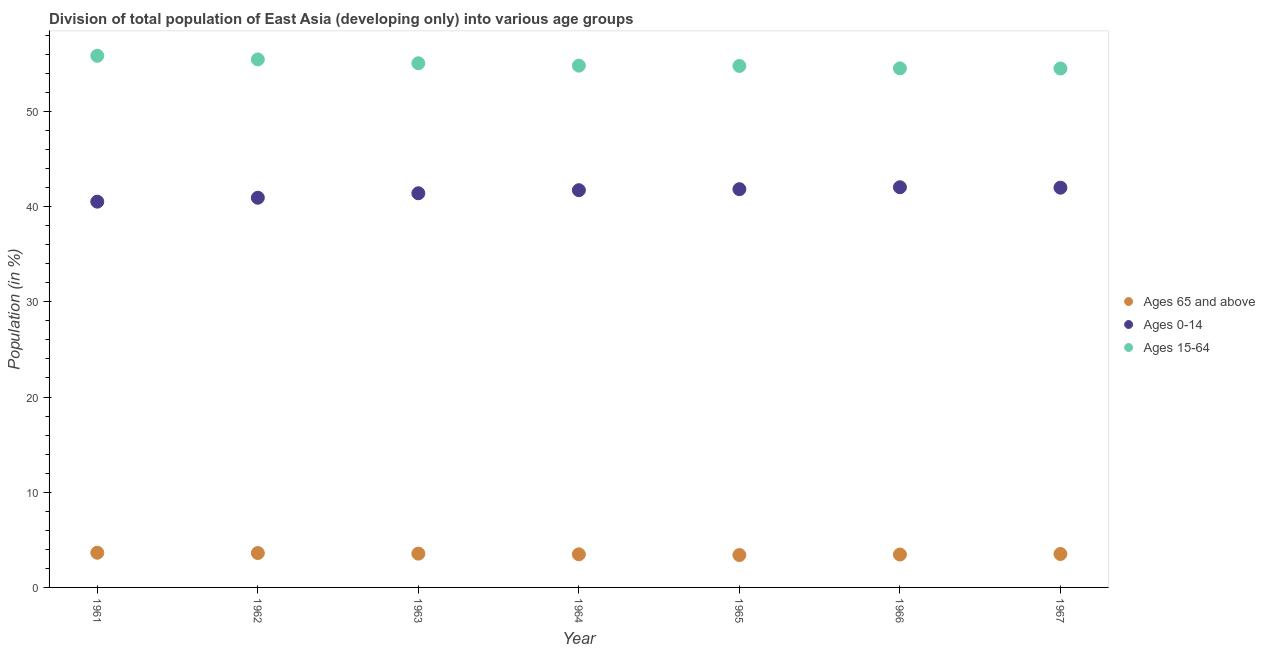How many different coloured dotlines are there?
Your answer should be very brief. 3. What is the percentage of population within the age-group of 65 and above in 1965?
Your answer should be very brief. 3.4. Across all years, what is the maximum percentage of population within the age-group of 65 and above?
Offer a terse response. 3.64. Across all years, what is the minimum percentage of population within the age-group of 65 and above?
Provide a short and direct response. 3.4. In which year was the percentage of population within the age-group 0-14 maximum?
Keep it short and to the point. 1966. In which year was the percentage of population within the age-group of 65 and above minimum?
Make the answer very short. 1965. What is the total percentage of population within the age-group 15-64 in the graph?
Ensure brevity in your answer.  384.93. What is the difference between the percentage of population within the age-group of 65 and above in 1961 and that in 1964?
Keep it short and to the point. 0.17. What is the difference between the percentage of population within the age-group 15-64 in 1963 and the percentage of population within the age-group 0-14 in 1967?
Your answer should be compact. 13.06. What is the average percentage of population within the age-group 0-14 per year?
Provide a succinct answer. 41.49. In the year 1966, what is the difference between the percentage of population within the age-group 15-64 and percentage of population within the age-group 0-14?
Give a very brief answer. 12.48. In how many years, is the percentage of population within the age-group of 65 and above greater than 6 %?
Make the answer very short. 0. What is the ratio of the percentage of population within the age-group 0-14 in 1962 to that in 1964?
Provide a short and direct response. 0.98. Is the percentage of population within the age-group 0-14 in 1961 less than that in 1967?
Your answer should be compact. Yes. Is the difference between the percentage of population within the age-group 0-14 in 1961 and 1963 greater than the difference between the percentage of population within the age-group of 65 and above in 1961 and 1963?
Offer a terse response. No. What is the difference between the highest and the second highest percentage of population within the age-group of 65 and above?
Provide a short and direct response. 0.03. What is the difference between the highest and the lowest percentage of population within the age-group of 65 and above?
Your answer should be compact. 0.24. Is the sum of the percentage of population within the age-group 15-64 in 1963 and 1966 greater than the maximum percentage of population within the age-group of 65 and above across all years?
Provide a succinct answer. Yes. Is the percentage of population within the age-group of 65 and above strictly greater than the percentage of population within the age-group 0-14 over the years?
Your response must be concise. No. How many years are there in the graph?
Offer a terse response. 7. What is the difference between two consecutive major ticks on the Y-axis?
Offer a very short reply. 10. Are the values on the major ticks of Y-axis written in scientific E-notation?
Your answer should be compact. No. Does the graph contain any zero values?
Ensure brevity in your answer.  No. Where does the legend appear in the graph?
Your answer should be compact. Center right. How many legend labels are there?
Offer a very short reply. 3. How are the legend labels stacked?
Make the answer very short. Vertical. What is the title of the graph?
Your answer should be very brief. Division of total population of East Asia (developing only) into various age groups
. Does "Agricultural raw materials" appear as one of the legend labels in the graph?
Provide a succinct answer. No. What is the label or title of the X-axis?
Your answer should be compact. Year. What is the Population (in %) in Ages 65 and above in 1961?
Offer a very short reply. 3.64. What is the Population (in %) in Ages 0-14 in 1961?
Ensure brevity in your answer.  40.52. What is the Population (in %) of Ages 15-64 in 1961?
Your answer should be very brief. 55.84. What is the Population (in %) in Ages 65 and above in 1962?
Ensure brevity in your answer.  3.61. What is the Population (in %) of Ages 0-14 in 1962?
Provide a short and direct response. 40.93. What is the Population (in %) of Ages 15-64 in 1962?
Provide a short and direct response. 55.46. What is the Population (in %) of Ages 65 and above in 1963?
Your answer should be compact. 3.55. What is the Population (in %) in Ages 0-14 in 1963?
Provide a succinct answer. 41.4. What is the Population (in %) in Ages 15-64 in 1963?
Ensure brevity in your answer.  55.05. What is the Population (in %) in Ages 65 and above in 1964?
Provide a short and direct response. 3.48. What is the Population (in %) of Ages 0-14 in 1964?
Keep it short and to the point. 41.72. What is the Population (in %) in Ages 15-64 in 1964?
Keep it short and to the point. 54.8. What is the Population (in %) of Ages 65 and above in 1965?
Offer a terse response. 3.4. What is the Population (in %) of Ages 0-14 in 1965?
Keep it short and to the point. 41.83. What is the Population (in %) of Ages 15-64 in 1965?
Provide a short and direct response. 54.77. What is the Population (in %) in Ages 65 and above in 1966?
Provide a succinct answer. 3.46. What is the Population (in %) in Ages 0-14 in 1966?
Your response must be concise. 42.03. What is the Population (in %) of Ages 15-64 in 1966?
Your answer should be very brief. 54.51. What is the Population (in %) of Ages 65 and above in 1967?
Offer a terse response. 3.51. What is the Population (in %) of Ages 0-14 in 1967?
Provide a short and direct response. 41.99. What is the Population (in %) of Ages 15-64 in 1967?
Ensure brevity in your answer.  54.5. Across all years, what is the maximum Population (in %) of Ages 65 and above?
Ensure brevity in your answer.  3.64. Across all years, what is the maximum Population (in %) in Ages 0-14?
Your answer should be very brief. 42.03. Across all years, what is the maximum Population (in %) in Ages 15-64?
Ensure brevity in your answer.  55.84. Across all years, what is the minimum Population (in %) of Ages 65 and above?
Provide a short and direct response. 3.4. Across all years, what is the minimum Population (in %) in Ages 0-14?
Your response must be concise. 40.52. Across all years, what is the minimum Population (in %) in Ages 15-64?
Make the answer very short. 54.5. What is the total Population (in %) of Ages 65 and above in the graph?
Give a very brief answer. 24.65. What is the total Population (in %) in Ages 0-14 in the graph?
Your answer should be very brief. 290.41. What is the total Population (in %) of Ages 15-64 in the graph?
Ensure brevity in your answer.  384.93. What is the difference between the Population (in %) of Ages 65 and above in 1961 and that in 1962?
Your response must be concise. 0.03. What is the difference between the Population (in %) in Ages 0-14 in 1961 and that in 1962?
Provide a short and direct response. -0.41. What is the difference between the Population (in %) of Ages 15-64 in 1961 and that in 1962?
Provide a succinct answer. 0.38. What is the difference between the Population (in %) of Ages 65 and above in 1961 and that in 1963?
Keep it short and to the point. 0.09. What is the difference between the Population (in %) of Ages 0-14 in 1961 and that in 1963?
Give a very brief answer. -0.88. What is the difference between the Population (in %) in Ages 15-64 in 1961 and that in 1963?
Your answer should be compact. 0.79. What is the difference between the Population (in %) in Ages 65 and above in 1961 and that in 1964?
Your answer should be compact. 0.17. What is the difference between the Population (in %) in Ages 0-14 in 1961 and that in 1964?
Your response must be concise. -1.2. What is the difference between the Population (in %) of Ages 15-64 in 1961 and that in 1964?
Make the answer very short. 1.04. What is the difference between the Population (in %) in Ages 65 and above in 1961 and that in 1965?
Ensure brevity in your answer.  0.24. What is the difference between the Population (in %) in Ages 0-14 in 1961 and that in 1965?
Offer a very short reply. -1.31. What is the difference between the Population (in %) in Ages 15-64 in 1961 and that in 1965?
Ensure brevity in your answer.  1.07. What is the difference between the Population (in %) in Ages 65 and above in 1961 and that in 1966?
Offer a very short reply. 0.19. What is the difference between the Population (in %) in Ages 0-14 in 1961 and that in 1966?
Ensure brevity in your answer.  -1.51. What is the difference between the Population (in %) of Ages 15-64 in 1961 and that in 1966?
Offer a terse response. 1.32. What is the difference between the Population (in %) in Ages 65 and above in 1961 and that in 1967?
Ensure brevity in your answer.  0.13. What is the difference between the Population (in %) of Ages 0-14 in 1961 and that in 1967?
Your answer should be compact. -1.47. What is the difference between the Population (in %) in Ages 15-64 in 1961 and that in 1967?
Make the answer very short. 1.34. What is the difference between the Population (in %) of Ages 65 and above in 1962 and that in 1963?
Provide a succinct answer. 0.06. What is the difference between the Population (in %) of Ages 0-14 in 1962 and that in 1963?
Your response must be concise. -0.47. What is the difference between the Population (in %) in Ages 15-64 in 1962 and that in 1963?
Give a very brief answer. 0.41. What is the difference between the Population (in %) of Ages 65 and above in 1962 and that in 1964?
Offer a very short reply. 0.13. What is the difference between the Population (in %) in Ages 0-14 in 1962 and that in 1964?
Make the answer very short. -0.79. What is the difference between the Population (in %) of Ages 15-64 in 1962 and that in 1964?
Your answer should be compact. 0.66. What is the difference between the Population (in %) in Ages 65 and above in 1962 and that in 1965?
Provide a short and direct response. 0.21. What is the difference between the Population (in %) of Ages 0-14 in 1962 and that in 1965?
Keep it short and to the point. -0.9. What is the difference between the Population (in %) of Ages 15-64 in 1962 and that in 1965?
Your answer should be very brief. 0.69. What is the difference between the Population (in %) of Ages 65 and above in 1962 and that in 1966?
Your response must be concise. 0.16. What is the difference between the Population (in %) of Ages 0-14 in 1962 and that in 1966?
Provide a succinct answer. -1.1. What is the difference between the Population (in %) in Ages 15-64 in 1962 and that in 1966?
Give a very brief answer. 0.95. What is the difference between the Population (in %) in Ages 65 and above in 1962 and that in 1967?
Make the answer very short. 0.1. What is the difference between the Population (in %) of Ages 0-14 in 1962 and that in 1967?
Make the answer very short. -1.06. What is the difference between the Population (in %) of Ages 15-64 in 1962 and that in 1967?
Your answer should be compact. 0.96. What is the difference between the Population (in %) in Ages 65 and above in 1963 and that in 1964?
Keep it short and to the point. 0.07. What is the difference between the Population (in %) of Ages 0-14 in 1963 and that in 1964?
Provide a short and direct response. -0.32. What is the difference between the Population (in %) in Ages 15-64 in 1963 and that in 1964?
Your answer should be compact. 0.25. What is the difference between the Population (in %) in Ages 65 and above in 1963 and that in 1965?
Keep it short and to the point. 0.15. What is the difference between the Population (in %) of Ages 0-14 in 1963 and that in 1965?
Keep it short and to the point. -0.43. What is the difference between the Population (in %) in Ages 15-64 in 1963 and that in 1965?
Make the answer very short. 0.28. What is the difference between the Population (in %) of Ages 65 and above in 1963 and that in 1966?
Ensure brevity in your answer.  0.09. What is the difference between the Population (in %) of Ages 0-14 in 1963 and that in 1966?
Provide a short and direct response. -0.63. What is the difference between the Population (in %) of Ages 15-64 in 1963 and that in 1966?
Give a very brief answer. 0.54. What is the difference between the Population (in %) in Ages 65 and above in 1963 and that in 1967?
Give a very brief answer. 0.04. What is the difference between the Population (in %) in Ages 0-14 in 1963 and that in 1967?
Offer a terse response. -0.59. What is the difference between the Population (in %) of Ages 15-64 in 1963 and that in 1967?
Provide a succinct answer. 0.55. What is the difference between the Population (in %) of Ages 65 and above in 1964 and that in 1965?
Your answer should be very brief. 0.08. What is the difference between the Population (in %) of Ages 0-14 in 1964 and that in 1965?
Ensure brevity in your answer.  -0.11. What is the difference between the Population (in %) of Ages 15-64 in 1964 and that in 1965?
Offer a terse response. 0.03. What is the difference between the Population (in %) of Ages 65 and above in 1964 and that in 1966?
Ensure brevity in your answer.  0.02. What is the difference between the Population (in %) of Ages 0-14 in 1964 and that in 1966?
Give a very brief answer. -0.31. What is the difference between the Population (in %) of Ages 15-64 in 1964 and that in 1966?
Your answer should be compact. 0.29. What is the difference between the Population (in %) of Ages 65 and above in 1964 and that in 1967?
Your answer should be very brief. -0.03. What is the difference between the Population (in %) of Ages 0-14 in 1964 and that in 1967?
Offer a terse response. -0.27. What is the difference between the Population (in %) of Ages 15-64 in 1964 and that in 1967?
Provide a short and direct response. 0.3. What is the difference between the Population (in %) in Ages 65 and above in 1965 and that in 1966?
Make the answer very short. -0.05. What is the difference between the Population (in %) in Ages 0-14 in 1965 and that in 1966?
Your response must be concise. -0.2. What is the difference between the Population (in %) of Ages 15-64 in 1965 and that in 1966?
Your answer should be very brief. 0.26. What is the difference between the Population (in %) in Ages 65 and above in 1965 and that in 1967?
Ensure brevity in your answer.  -0.11. What is the difference between the Population (in %) in Ages 0-14 in 1965 and that in 1967?
Offer a terse response. -0.16. What is the difference between the Population (in %) in Ages 15-64 in 1965 and that in 1967?
Your answer should be very brief. 0.27. What is the difference between the Population (in %) of Ages 65 and above in 1966 and that in 1967?
Provide a succinct answer. -0.06. What is the difference between the Population (in %) of Ages 0-14 in 1966 and that in 1967?
Give a very brief answer. 0.04. What is the difference between the Population (in %) of Ages 15-64 in 1966 and that in 1967?
Your answer should be compact. 0.01. What is the difference between the Population (in %) of Ages 65 and above in 1961 and the Population (in %) of Ages 0-14 in 1962?
Make the answer very short. -37.28. What is the difference between the Population (in %) in Ages 65 and above in 1961 and the Population (in %) in Ages 15-64 in 1962?
Your answer should be compact. -51.81. What is the difference between the Population (in %) in Ages 0-14 in 1961 and the Population (in %) in Ages 15-64 in 1962?
Provide a succinct answer. -14.94. What is the difference between the Population (in %) in Ages 65 and above in 1961 and the Population (in %) in Ages 0-14 in 1963?
Provide a succinct answer. -37.76. What is the difference between the Population (in %) of Ages 65 and above in 1961 and the Population (in %) of Ages 15-64 in 1963?
Provide a succinct answer. -51.41. What is the difference between the Population (in %) of Ages 0-14 in 1961 and the Population (in %) of Ages 15-64 in 1963?
Give a very brief answer. -14.53. What is the difference between the Population (in %) of Ages 65 and above in 1961 and the Population (in %) of Ages 0-14 in 1964?
Ensure brevity in your answer.  -38.08. What is the difference between the Population (in %) in Ages 65 and above in 1961 and the Population (in %) in Ages 15-64 in 1964?
Your answer should be very brief. -51.16. What is the difference between the Population (in %) of Ages 0-14 in 1961 and the Population (in %) of Ages 15-64 in 1964?
Ensure brevity in your answer.  -14.28. What is the difference between the Population (in %) in Ages 65 and above in 1961 and the Population (in %) in Ages 0-14 in 1965?
Make the answer very short. -38.18. What is the difference between the Population (in %) of Ages 65 and above in 1961 and the Population (in %) of Ages 15-64 in 1965?
Make the answer very short. -51.13. What is the difference between the Population (in %) in Ages 0-14 in 1961 and the Population (in %) in Ages 15-64 in 1965?
Offer a terse response. -14.25. What is the difference between the Population (in %) in Ages 65 and above in 1961 and the Population (in %) in Ages 0-14 in 1966?
Provide a succinct answer. -38.39. What is the difference between the Population (in %) in Ages 65 and above in 1961 and the Population (in %) in Ages 15-64 in 1966?
Your answer should be compact. -50.87. What is the difference between the Population (in %) in Ages 0-14 in 1961 and the Population (in %) in Ages 15-64 in 1966?
Your answer should be compact. -14. What is the difference between the Population (in %) of Ages 65 and above in 1961 and the Population (in %) of Ages 0-14 in 1967?
Provide a short and direct response. -38.34. What is the difference between the Population (in %) in Ages 65 and above in 1961 and the Population (in %) in Ages 15-64 in 1967?
Your answer should be compact. -50.86. What is the difference between the Population (in %) in Ages 0-14 in 1961 and the Population (in %) in Ages 15-64 in 1967?
Make the answer very short. -13.98. What is the difference between the Population (in %) in Ages 65 and above in 1962 and the Population (in %) in Ages 0-14 in 1963?
Ensure brevity in your answer.  -37.79. What is the difference between the Population (in %) in Ages 65 and above in 1962 and the Population (in %) in Ages 15-64 in 1963?
Give a very brief answer. -51.44. What is the difference between the Population (in %) in Ages 0-14 in 1962 and the Population (in %) in Ages 15-64 in 1963?
Ensure brevity in your answer.  -14.12. What is the difference between the Population (in %) in Ages 65 and above in 1962 and the Population (in %) in Ages 0-14 in 1964?
Give a very brief answer. -38.11. What is the difference between the Population (in %) in Ages 65 and above in 1962 and the Population (in %) in Ages 15-64 in 1964?
Ensure brevity in your answer.  -51.19. What is the difference between the Population (in %) of Ages 0-14 in 1962 and the Population (in %) of Ages 15-64 in 1964?
Your response must be concise. -13.87. What is the difference between the Population (in %) of Ages 65 and above in 1962 and the Population (in %) of Ages 0-14 in 1965?
Your response must be concise. -38.22. What is the difference between the Population (in %) in Ages 65 and above in 1962 and the Population (in %) in Ages 15-64 in 1965?
Your answer should be compact. -51.16. What is the difference between the Population (in %) in Ages 0-14 in 1962 and the Population (in %) in Ages 15-64 in 1965?
Make the answer very short. -13.84. What is the difference between the Population (in %) of Ages 65 and above in 1962 and the Population (in %) of Ages 0-14 in 1966?
Your answer should be very brief. -38.42. What is the difference between the Population (in %) of Ages 65 and above in 1962 and the Population (in %) of Ages 15-64 in 1966?
Keep it short and to the point. -50.9. What is the difference between the Population (in %) of Ages 0-14 in 1962 and the Population (in %) of Ages 15-64 in 1966?
Your answer should be compact. -13.58. What is the difference between the Population (in %) of Ages 65 and above in 1962 and the Population (in %) of Ages 0-14 in 1967?
Your response must be concise. -38.37. What is the difference between the Population (in %) of Ages 65 and above in 1962 and the Population (in %) of Ages 15-64 in 1967?
Offer a terse response. -50.89. What is the difference between the Population (in %) of Ages 0-14 in 1962 and the Population (in %) of Ages 15-64 in 1967?
Make the answer very short. -13.57. What is the difference between the Population (in %) in Ages 65 and above in 1963 and the Population (in %) in Ages 0-14 in 1964?
Your response must be concise. -38.17. What is the difference between the Population (in %) in Ages 65 and above in 1963 and the Population (in %) in Ages 15-64 in 1964?
Give a very brief answer. -51.25. What is the difference between the Population (in %) in Ages 0-14 in 1963 and the Population (in %) in Ages 15-64 in 1964?
Offer a very short reply. -13.4. What is the difference between the Population (in %) in Ages 65 and above in 1963 and the Population (in %) in Ages 0-14 in 1965?
Make the answer very short. -38.28. What is the difference between the Population (in %) of Ages 65 and above in 1963 and the Population (in %) of Ages 15-64 in 1965?
Give a very brief answer. -51.22. What is the difference between the Population (in %) of Ages 0-14 in 1963 and the Population (in %) of Ages 15-64 in 1965?
Your response must be concise. -13.37. What is the difference between the Population (in %) in Ages 65 and above in 1963 and the Population (in %) in Ages 0-14 in 1966?
Ensure brevity in your answer.  -38.48. What is the difference between the Population (in %) of Ages 65 and above in 1963 and the Population (in %) of Ages 15-64 in 1966?
Offer a terse response. -50.96. What is the difference between the Population (in %) in Ages 0-14 in 1963 and the Population (in %) in Ages 15-64 in 1966?
Your answer should be very brief. -13.11. What is the difference between the Population (in %) in Ages 65 and above in 1963 and the Population (in %) in Ages 0-14 in 1967?
Your answer should be compact. -38.44. What is the difference between the Population (in %) in Ages 65 and above in 1963 and the Population (in %) in Ages 15-64 in 1967?
Provide a short and direct response. -50.95. What is the difference between the Population (in %) in Ages 0-14 in 1963 and the Population (in %) in Ages 15-64 in 1967?
Your answer should be compact. -13.1. What is the difference between the Population (in %) in Ages 65 and above in 1964 and the Population (in %) in Ages 0-14 in 1965?
Ensure brevity in your answer.  -38.35. What is the difference between the Population (in %) of Ages 65 and above in 1964 and the Population (in %) of Ages 15-64 in 1965?
Offer a terse response. -51.29. What is the difference between the Population (in %) of Ages 0-14 in 1964 and the Population (in %) of Ages 15-64 in 1965?
Make the answer very short. -13.05. What is the difference between the Population (in %) in Ages 65 and above in 1964 and the Population (in %) in Ages 0-14 in 1966?
Ensure brevity in your answer.  -38.55. What is the difference between the Population (in %) of Ages 65 and above in 1964 and the Population (in %) of Ages 15-64 in 1966?
Ensure brevity in your answer.  -51.04. What is the difference between the Population (in %) in Ages 0-14 in 1964 and the Population (in %) in Ages 15-64 in 1966?
Your response must be concise. -12.79. What is the difference between the Population (in %) in Ages 65 and above in 1964 and the Population (in %) in Ages 0-14 in 1967?
Ensure brevity in your answer.  -38.51. What is the difference between the Population (in %) of Ages 65 and above in 1964 and the Population (in %) of Ages 15-64 in 1967?
Your response must be concise. -51.02. What is the difference between the Population (in %) in Ages 0-14 in 1964 and the Population (in %) in Ages 15-64 in 1967?
Make the answer very short. -12.78. What is the difference between the Population (in %) of Ages 65 and above in 1965 and the Population (in %) of Ages 0-14 in 1966?
Make the answer very short. -38.63. What is the difference between the Population (in %) of Ages 65 and above in 1965 and the Population (in %) of Ages 15-64 in 1966?
Your answer should be very brief. -51.11. What is the difference between the Population (in %) in Ages 0-14 in 1965 and the Population (in %) in Ages 15-64 in 1966?
Your answer should be very brief. -12.69. What is the difference between the Population (in %) of Ages 65 and above in 1965 and the Population (in %) of Ages 0-14 in 1967?
Give a very brief answer. -38.58. What is the difference between the Population (in %) of Ages 65 and above in 1965 and the Population (in %) of Ages 15-64 in 1967?
Provide a succinct answer. -51.1. What is the difference between the Population (in %) in Ages 0-14 in 1965 and the Population (in %) in Ages 15-64 in 1967?
Your answer should be compact. -12.67. What is the difference between the Population (in %) in Ages 65 and above in 1966 and the Population (in %) in Ages 0-14 in 1967?
Your answer should be compact. -38.53. What is the difference between the Population (in %) of Ages 65 and above in 1966 and the Population (in %) of Ages 15-64 in 1967?
Give a very brief answer. -51.05. What is the difference between the Population (in %) in Ages 0-14 in 1966 and the Population (in %) in Ages 15-64 in 1967?
Offer a very short reply. -12.47. What is the average Population (in %) of Ages 65 and above per year?
Provide a short and direct response. 3.52. What is the average Population (in %) of Ages 0-14 per year?
Provide a succinct answer. 41.49. What is the average Population (in %) in Ages 15-64 per year?
Provide a short and direct response. 54.99. In the year 1961, what is the difference between the Population (in %) in Ages 65 and above and Population (in %) in Ages 0-14?
Your response must be concise. -36.87. In the year 1961, what is the difference between the Population (in %) in Ages 65 and above and Population (in %) in Ages 15-64?
Your answer should be compact. -52.19. In the year 1961, what is the difference between the Population (in %) of Ages 0-14 and Population (in %) of Ages 15-64?
Provide a short and direct response. -15.32. In the year 1962, what is the difference between the Population (in %) in Ages 65 and above and Population (in %) in Ages 0-14?
Your answer should be compact. -37.32. In the year 1962, what is the difference between the Population (in %) of Ages 65 and above and Population (in %) of Ages 15-64?
Give a very brief answer. -51.85. In the year 1962, what is the difference between the Population (in %) in Ages 0-14 and Population (in %) in Ages 15-64?
Ensure brevity in your answer.  -14.53. In the year 1963, what is the difference between the Population (in %) in Ages 65 and above and Population (in %) in Ages 0-14?
Your answer should be compact. -37.85. In the year 1963, what is the difference between the Population (in %) of Ages 65 and above and Population (in %) of Ages 15-64?
Offer a terse response. -51.5. In the year 1963, what is the difference between the Population (in %) of Ages 0-14 and Population (in %) of Ages 15-64?
Offer a terse response. -13.65. In the year 1964, what is the difference between the Population (in %) of Ages 65 and above and Population (in %) of Ages 0-14?
Your answer should be compact. -38.24. In the year 1964, what is the difference between the Population (in %) in Ages 65 and above and Population (in %) in Ages 15-64?
Provide a succinct answer. -51.32. In the year 1964, what is the difference between the Population (in %) in Ages 0-14 and Population (in %) in Ages 15-64?
Your response must be concise. -13.08. In the year 1965, what is the difference between the Population (in %) in Ages 65 and above and Population (in %) in Ages 0-14?
Ensure brevity in your answer.  -38.43. In the year 1965, what is the difference between the Population (in %) of Ages 65 and above and Population (in %) of Ages 15-64?
Offer a terse response. -51.37. In the year 1965, what is the difference between the Population (in %) in Ages 0-14 and Population (in %) in Ages 15-64?
Make the answer very short. -12.94. In the year 1966, what is the difference between the Population (in %) of Ages 65 and above and Population (in %) of Ages 0-14?
Offer a terse response. -38.57. In the year 1966, what is the difference between the Population (in %) in Ages 65 and above and Population (in %) in Ages 15-64?
Ensure brevity in your answer.  -51.06. In the year 1966, what is the difference between the Population (in %) of Ages 0-14 and Population (in %) of Ages 15-64?
Keep it short and to the point. -12.48. In the year 1967, what is the difference between the Population (in %) of Ages 65 and above and Population (in %) of Ages 0-14?
Make the answer very short. -38.47. In the year 1967, what is the difference between the Population (in %) of Ages 65 and above and Population (in %) of Ages 15-64?
Provide a succinct answer. -50.99. In the year 1967, what is the difference between the Population (in %) in Ages 0-14 and Population (in %) in Ages 15-64?
Offer a very short reply. -12.52. What is the ratio of the Population (in %) of Ages 15-64 in 1961 to that in 1962?
Offer a terse response. 1.01. What is the ratio of the Population (in %) of Ages 65 and above in 1961 to that in 1963?
Your answer should be very brief. 1.03. What is the ratio of the Population (in %) of Ages 0-14 in 1961 to that in 1963?
Your answer should be compact. 0.98. What is the ratio of the Population (in %) in Ages 15-64 in 1961 to that in 1963?
Give a very brief answer. 1.01. What is the ratio of the Population (in %) of Ages 65 and above in 1961 to that in 1964?
Make the answer very short. 1.05. What is the ratio of the Population (in %) of Ages 0-14 in 1961 to that in 1964?
Keep it short and to the point. 0.97. What is the ratio of the Population (in %) of Ages 15-64 in 1961 to that in 1964?
Keep it short and to the point. 1.02. What is the ratio of the Population (in %) of Ages 65 and above in 1961 to that in 1965?
Offer a very short reply. 1.07. What is the ratio of the Population (in %) in Ages 0-14 in 1961 to that in 1965?
Your answer should be compact. 0.97. What is the ratio of the Population (in %) of Ages 15-64 in 1961 to that in 1965?
Offer a terse response. 1.02. What is the ratio of the Population (in %) of Ages 65 and above in 1961 to that in 1966?
Give a very brief answer. 1.05. What is the ratio of the Population (in %) of Ages 15-64 in 1961 to that in 1966?
Your answer should be compact. 1.02. What is the ratio of the Population (in %) in Ages 65 and above in 1961 to that in 1967?
Provide a succinct answer. 1.04. What is the ratio of the Population (in %) in Ages 15-64 in 1961 to that in 1967?
Your answer should be compact. 1.02. What is the ratio of the Population (in %) of Ages 65 and above in 1962 to that in 1963?
Offer a very short reply. 1.02. What is the ratio of the Population (in %) of Ages 15-64 in 1962 to that in 1963?
Your answer should be compact. 1.01. What is the ratio of the Population (in %) in Ages 65 and above in 1962 to that in 1964?
Provide a short and direct response. 1.04. What is the ratio of the Population (in %) in Ages 0-14 in 1962 to that in 1964?
Provide a short and direct response. 0.98. What is the ratio of the Population (in %) of Ages 65 and above in 1962 to that in 1965?
Provide a succinct answer. 1.06. What is the ratio of the Population (in %) of Ages 0-14 in 1962 to that in 1965?
Offer a terse response. 0.98. What is the ratio of the Population (in %) of Ages 15-64 in 1962 to that in 1965?
Your answer should be compact. 1.01. What is the ratio of the Population (in %) of Ages 65 and above in 1962 to that in 1966?
Your answer should be very brief. 1.05. What is the ratio of the Population (in %) in Ages 0-14 in 1962 to that in 1966?
Offer a terse response. 0.97. What is the ratio of the Population (in %) in Ages 15-64 in 1962 to that in 1966?
Your answer should be compact. 1.02. What is the ratio of the Population (in %) of Ages 65 and above in 1962 to that in 1967?
Your response must be concise. 1.03. What is the ratio of the Population (in %) in Ages 0-14 in 1962 to that in 1967?
Your answer should be compact. 0.97. What is the ratio of the Population (in %) of Ages 15-64 in 1962 to that in 1967?
Your response must be concise. 1.02. What is the ratio of the Population (in %) in Ages 65 and above in 1963 to that in 1964?
Make the answer very short. 1.02. What is the ratio of the Population (in %) of Ages 15-64 in 1963 to that in 1964?
Ensure brevity in your answer.  1. What is the ratio of the Population (in %) of Ages 65 and above in 1963 to that in 1965?
Offer a very short reply. 1.04. What is the ratio of the Population (in %) of Ages 0-14 in 1963 to that in 1965?
Offer a terse response. 0.99. What is the ratio of the Population (in %) of Ages 15-64 in 1963 to that in 1965?
Offer a very short reply. 1.01. What is the ratio of the Population (in %) in Ages 65 and above in 1963 to that in 1966?
Offer a terse response. 1.03. What is the ratio of the Population (in %) of Ages 0-14 in 1963 to that in 1966?
Your answer should be compact. 0.98. What is the ratio of the Population (in %) of Ages 15-64 in 1963 to that in 1966?
Give a very brief answer. 1.01. What is the ratio of the Population (in %) in Ages 65 and above in 1963 to that in 1967?
Your answer should be compact. 1.01. What is the ratio of the Population (in %) of Ages 0-14 in 1963 to that in 1967?
Your answer should be very brief. 0.99. What is the ratio of the Population (in %) in Ages 65 and above in 1964 to that in 1965?
Offer a terse response. 1.02. What is the ratio of the Population (in %) in Ages 0-14 in 1964 to that in 1965?
Your answer should be compact. 1. What is the ratio of the Population (in %) in Ages 15-64 in 1964 to that in 1965?
Provide a succinct answer. 1. What is the ratio of the Population (in %) in Ages 65 and above in 1964 to that in 1966?
Keep it short and to the point. 1.01. What is the ratio of the Population (in %) in Ages 0-14 in 1964 to that in 1966?
Make the answer very short. 0.99. What is the ratio of the Population (in %) of Ages 15-64 in 1964 to that in 1966?
Provide a short and direct response. 1.01. What is the ratio of the Population (in %) in Ages 65 and above in 1964 to that in 1967?
Your answer should be compact. 0.99. What is the ratio of the Population (in %) in Ages 0-14 in 1964 to that in 1967?
Give a very brief answer. 0.99. What is the ratio of the Population (in %) of Ages 65 and above in 1965 to that in 1966?
Offer a terse response. 0.98. What is the ratio of the Population (in %) in Ages 65 and above in 1965 to that in 1967?
Your answer should be compact. 0.97. What is the ratio of the Population (in %) in Ages 65 and above in 1966 to that in 1967?
Your answer should be very brief. 0.98. What is the ratio of the Population (in %) in Ages 0-14 in 1966 to that in 1967?
Provide a short and direct response. 1. What is the difference between the highest and the second highest Population (in %) of Ages 65 and above?
Your answer should be compact. 0.03. What is the difference between the highest and the second highest Population (in %) of Ages 0-14?
Ensure brevity in your answer.  0.04. What is the difference between the highest and the second highest Population (in %) in Ages 15-64?
Keep it short and to the point. 0.38. What is the difference between the highest and the lowest Population (in %) in Ages 65 and above?
Make the answer very short. 0.24. What is the difference between the highest and the lowest Population (in %) in Ages 0-14?
Your answer should be compact. 1.51. What is the difference between the highest and the lowest Population (in %) of Ages 15-64?
Provide a short and direct response. 1.34. 